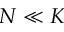Convert formula to latex. <formula><loc_0><loc_0><loc_500><loc_500>N \ll K</formula> 